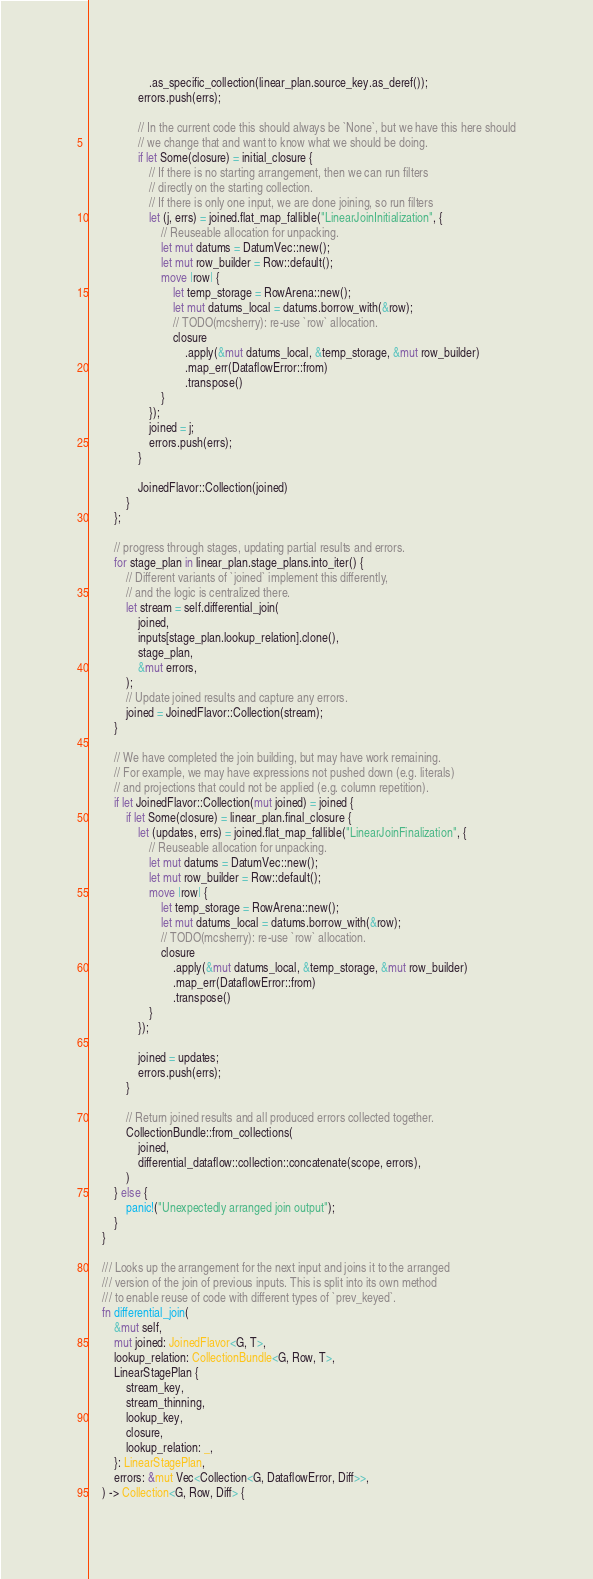<code> <loc_0><loc_0><loc_500><loc_500><_Rust_>                    .as_specific_collection(linear_plan.source_key.as_deref());
                errors.push(errs);

                // In the current code this should always be `None`, but we have this here should
                // we change that and want to know what we should be doing.
                if let Some(closure) = initial_closure {
                    // If there is no starting arrangement, then we can run filters
                    // directly on the starting collection.
                    // If there is only one input, we are done joining, so run filters
                    let (j, errs) = joined.flat_map_fallible("LinearJoinInitialization", {
                        // Reuseable allocation for unpacking.
                        let mut datums = DatumVec::new();
                        let mut row_builder = Row::default();
                        move |row| {
                            let temp_storage = RowArena::new();
                            let mut datums_local = datums.borrow_with(&row);
                            // TODO(mcsherry): re-use `row` allocation.
                            closure
                                .apply(&mut datums_local, &temp_storage, &mut row_builder)
                                .map_err(DataflowError::from)
                                .transpose()
                        }
                    });
                    joined = j;
                    errors.push(errs);
                }

                JoinedFlavor::Collection(joined)
            }
        };

        // progress through stages, updating partial results and errors.
        for stage_plan in linear_plan.stage_plans.into_iter() {
            // Different variants of `joined` implement this differently,
            // and the logic is centralized there.
            let stream = self.differential_join(
                joined,
                inputs[stage_plan.lookup_relation].clone(),
                stage_plan,
                &mut errors,
            );
            // Update joined results and capture any errors.
            joined = JoinedFlavor::Collection(stream);
        }

        // We have completed the join building, but may have work remaining.
        // For example, we may have expressions not pushed down (e.g. literals)
        // and projections that could not be applied (e.g. column repetition).
        if let JoinedFlavor::Collection(mut joined) = joined {
            if let Some(closure) = linear_plan.final_closure {
                let (updates, errs) = joined.flat_map_fallible("LinearJoinFinalization", {
                    // Reuseable allocation for unpacking.
                    let mut datums = DatumVec::new();
                    let mut row_builder = Row::default();
                    move |row| {
                        let temp_storage = RowArena::new();
                        let mut datums_local = datums.borrow_with(&row);
                        // TODO(mcsherry): re-use `row` allocation.
                        closure
                            .apply(&mut datums_local, &temp_storage, &mut row_builder)
                            .map_err(DataflowError::from)
                            .transpose()
                    }
                });

                joined = updates;
                errors.push(errs);
            }

            // Return joined results and all produced errors collected together.
            CollectionBundle::from_collections(
                joined,
                differential_dataflow::collection::concatenate(scope, errors),
            )
        } else {
            panic!("Unexpectedly arranged join output");
        }
    }

    /// Looks up the arrangement for the next input and joins it to the arranged
    /// version of the join of previous inputs. This is split into its own method
    /// to enable reuse of code with different types of `prev_keyed`.
    fn differential_join(
        &mut self,
        mut joined: JoinedFlavor<G, T>,
        lookup_relation: CollectionBundle<G, Row, T>,
        LinearStagePlan {
            stream_key,
            stream_thinning,
            lookup_key,
            closure,
            lookup_relation: _,
        }: LinearStagePlan,
        errors: &mut Vec<Collection<G, DataflowError, Diff>>,
    ) -> Collection<G, Row, Diff> {</code> 